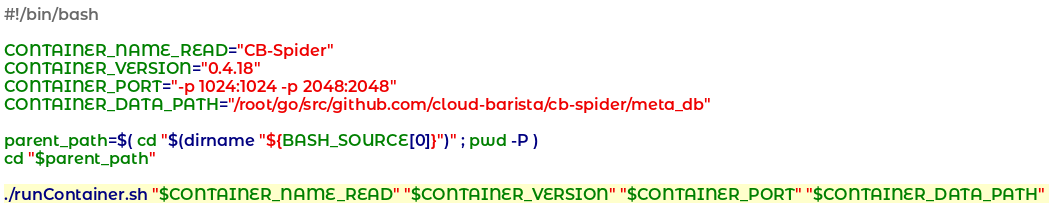<code> <loc_0><loc_0><loc_500><loc_500><_Bash_>#!/bin/bash

CONTAINER_NAME_READ="CB-Spider"
CONTAINER_VERSION="0.4.18"
CONTAINER_PORT="-p 1024:1024 -p 2048:2048"
CONTAINER_DATA_PATH="/root/go/src/github.com/cloud-barista/cb-spider/meta_db"

parent_path=$( cd "$(dirname "${BASH_SOURCE[0]}")" ; pwd -P )
cd "$parent_path"

./runContainer.sh "$CONTAINER_NAME_READ" "$CONTAINER_VERSION" "$CONTAINER_PORT" "$CONTAINER_DATA_PATH"
</code> 